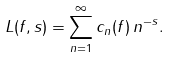Convert formula to latex. <formula><loc_0><loc_0><loc_500><loc_500>L ( f , s ) = \sum _ { n = 1 } ^ { \infty } c _ { n } ( f ) \, n ^ { - s } .</formula> 